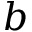Convert formula to latex. <formula><loc_0><loc_0><loc_500><loc_500>b</formula> 